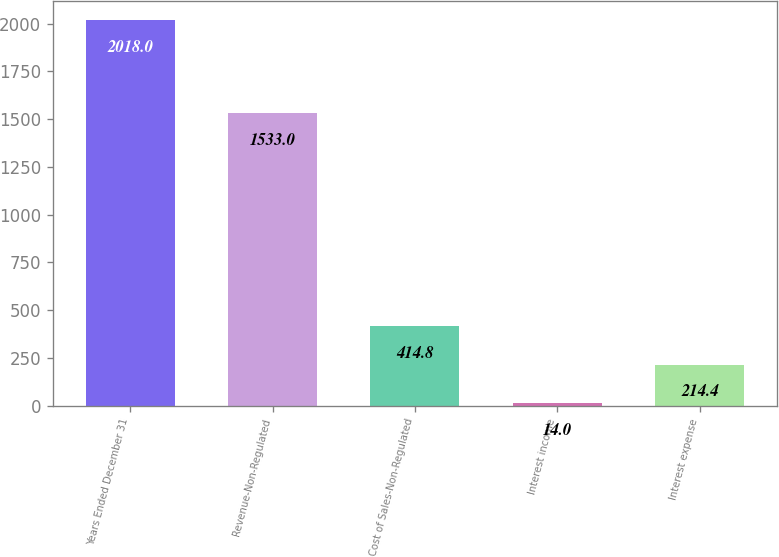Convert chart. <chart><loc_0><loc_0><loc_500><loc_500><bar_chart><fcel>Years Ended December 31<fcel>Revenue-Non-Regulated<fcel>Cost of Sales-Non-Regulated<fcel>Interest income<fcel>Interest expense<nl><fcel>2018<fcel>1533<fcel>414.8<fcel>14<fcel>214.4<nl></chart> 